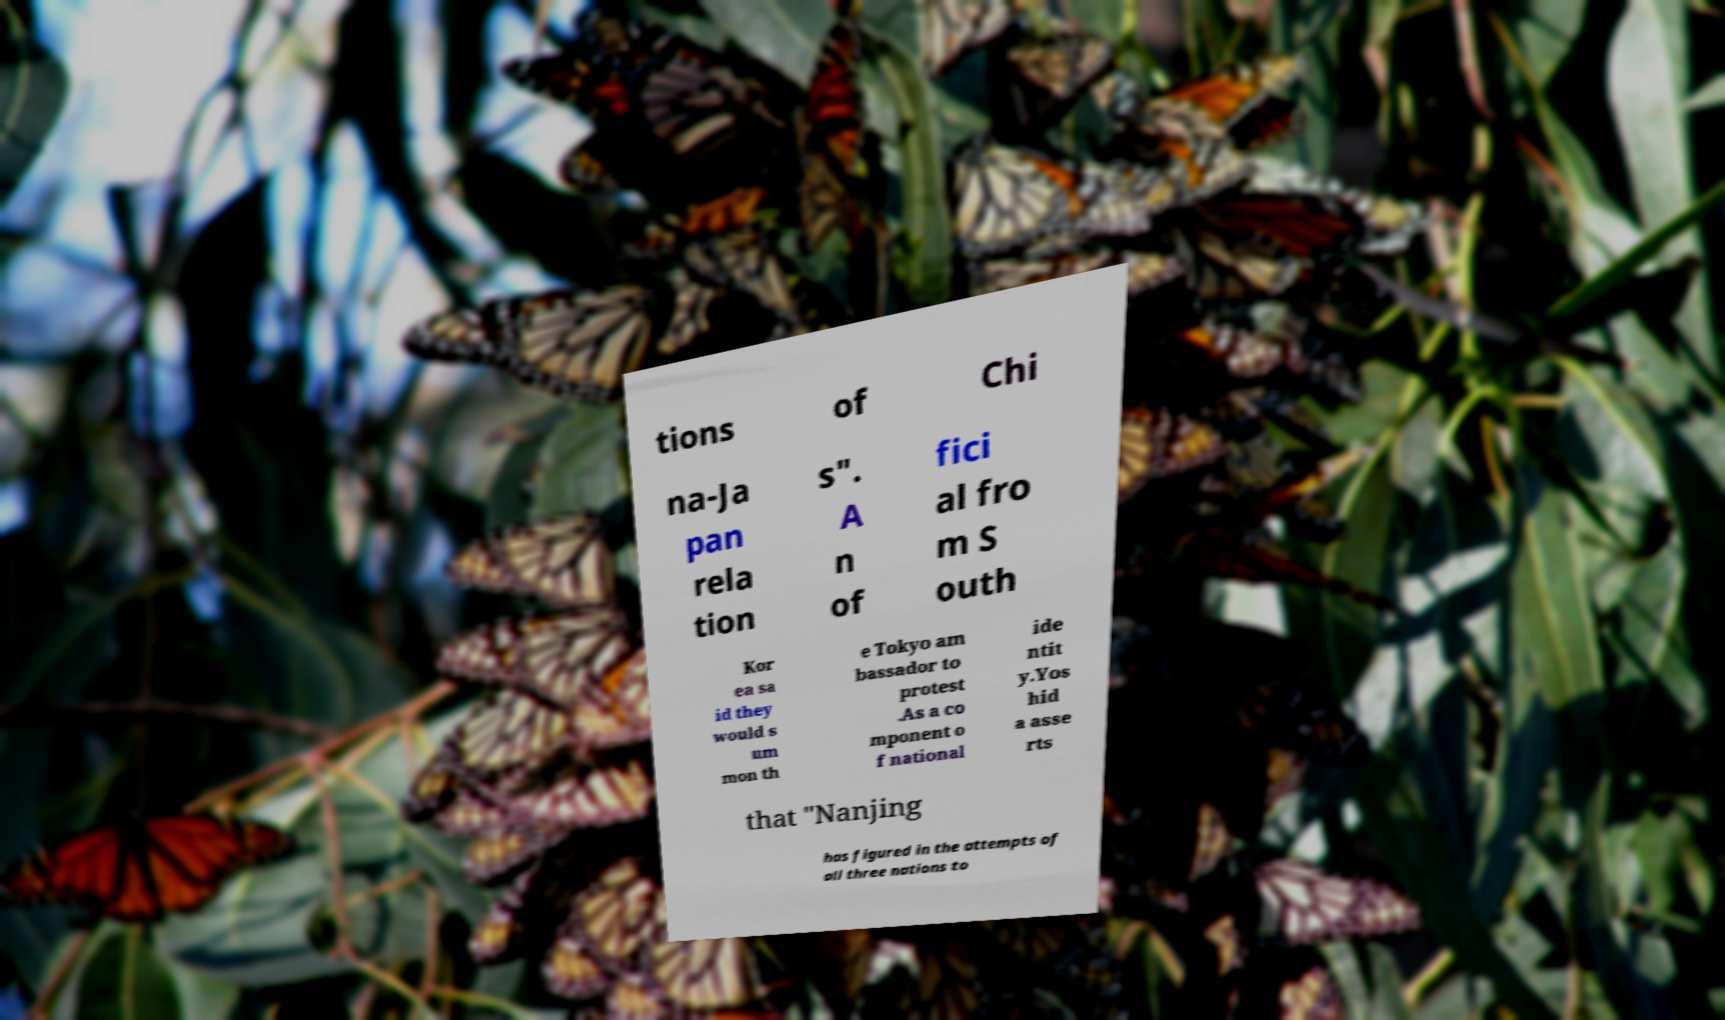Could you extract and type out the text from this image? tions of Chi na-Ja pan rela tion s". A n of fici al fro m S outh Kor ea sa id they would s um mon th e Tokyo am bassador to protest .As a co mponent o f national ide ntit y.Yos hid a asse rts that "Nanjing has figured in the attempts of all three nations to 